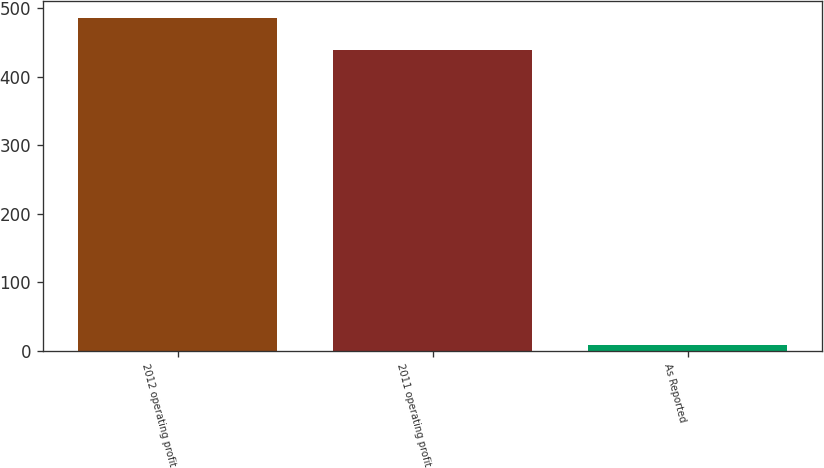Convert chart to OTSL. <chart><loc_0><loc_0><loc_500><loc_500><bar_chart><fcel>2012 operating profit<fcel>2011 operating profit<fcel>As Reported<nl><fcel>485.77<fcel>439<fcel>8.3<nl></chart> 